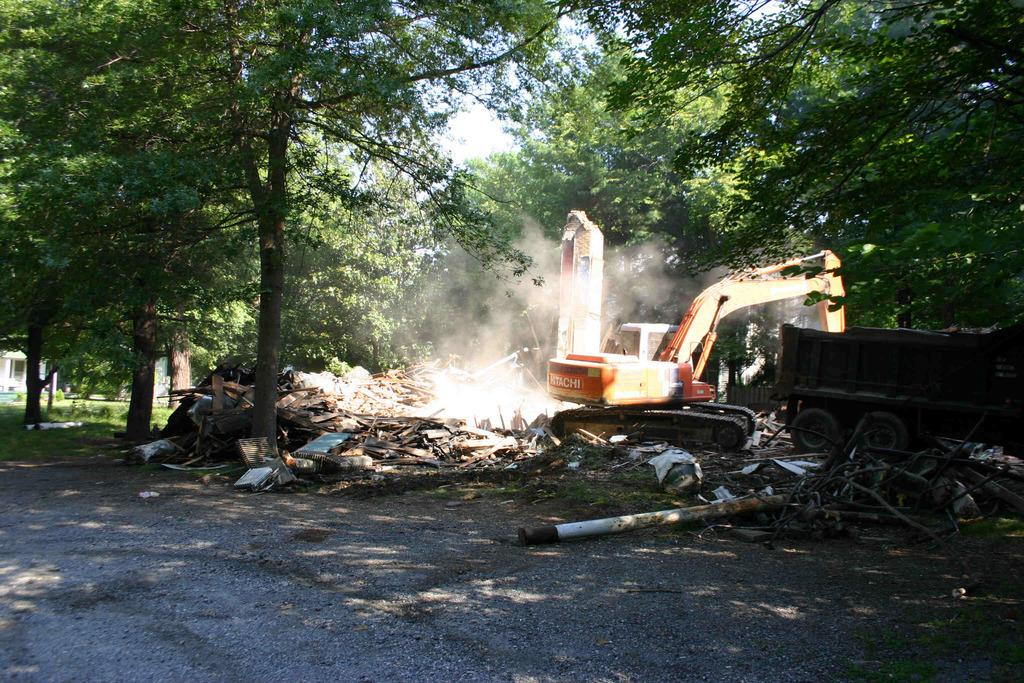What types of objects can be seen in the image? There are vehicles, wooden objects, trees, and poles in the image. What kind of surface is present in the image? There is a walkway in the image. What can be seen in the background of the image? The sky is visible in the background of the image. How comfortable is the yard in the image? There is no yard present in the image, so it is not possible to determine its comfort level. 